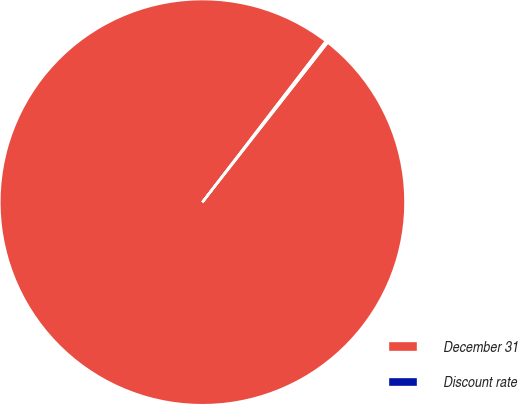Convert chart. <chart><loc_0><loc_0><loc_500><loc_500><pie_chart><fcel>December 31<fcel>Discount rate<nl><fcel>99.83%<fcel>0.17%<nl></chart> 